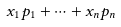<formula> <loc_0><loc_0><loc_500><loc_500>x _ { 1 } p _ { 1 } + \dots + x _ { n } p _ { n }</formula> 